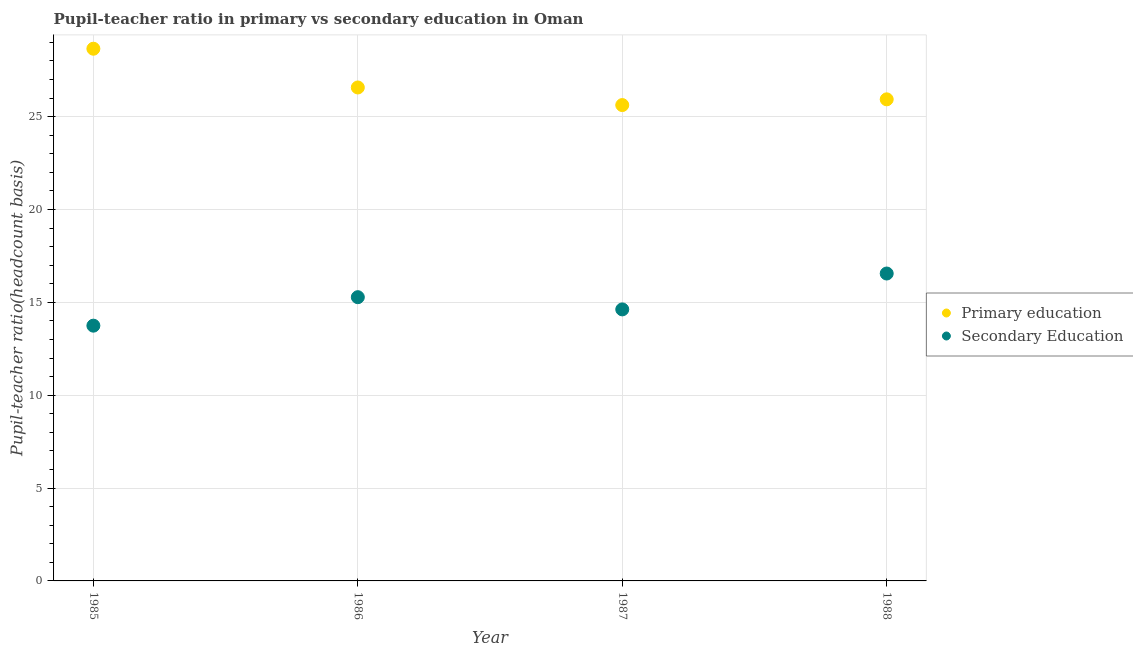Is the number of dotlines equal to the number of legend labels?
Provide a short and direct response. Yes. What is the pupil teacher ratio on secondary education in 1988?
Your answer should be compact. 16.55. Across all years, what is the maximum pupil-teacher ratio in primary education?
Offer a terse response. 28.66. Across all years, what is the minimum pupil teacher ratio on secondary education?
Give a very brief answer. 13.75. In which year was the pupil teacher ratio on secondary education maximum?
Keep it short and to the point. 1988. What is the total pupil teacher ratio on secondary education in the graph?
Offer a very short reply. 60.2. What is the difference between the pupil-teacher ratio in primary education in 1987 and that in 1988?
Your response must be concise. -0.31. What is the difference between the pupil teacher ratio on secondary education in 1987 and the pupil-teacher ratio in primary education in 1986?
Make the answer very short. -11.95. What is the average pupil-teacher ratio in primary education per year?
Offer a very short reply. 26.7. In the year 1986, what is the difference between the pupil-teacher ratio in primary education and pupil teacher ratio on secondary education?
Your response must be concise. 11.29. What is the ratio of the pupil-teacher ratio in primary education in 1985 to that in 1986?
Your answer should be very brief. 1.08. Is the pupil teacher ratio on secondary education in 1986 less than that in 1987?
Your answer should be very brief. No. Is the difference between the pupil-teacher ratio in primary education in 1986 and 1987 greater than the difference between the pupil teacher ratio on secondary education in 1986 and 1987?
Keep it short and to the point. Yes. What is the difference between the highest and the second highest pupil teacher ratio on secondary education?
Ensure brevity in your answer.  1.27. What is the difference between the highest and the lowest pupil-teacher ratio in primary education?
Ensure brevity in your answer.  3.03. Does the pupil teacher ratio on secondary education monotonically increase over the years?
Provide a short and direct response. No. Is the pupil-teacher ratio in primary education strictly greater than the pupil teacher ratio on secondary education over the years?
Make the answer very short. Yes. How many dotlines are there?
Ensure brevity in your answer.  2. How many years are there in the graph?
Your answer should be very brief. 4. What is the difference between two consecutive major ticks on the Y-axis?
Ensure brevity in your answer.  5. Does the graph contain any zero values?
Offer a terse response. No. Where does the legend appear in the graph?
Provide a short and direct response. Center right. How are the legend labels stacked?
Give a very brief answer. Vertical. What is the title of the graph?
Offer a terse response. Pupil-teacher ratio in primary vs secondary education in Oman. Does "RDB nonconcessional" appear as one of the legend labels in the graph?
Your answer should be compact. No. What is the label or title of the Y-axis?
Your answer should be very brief. Pupil-teacher ratio(headcount basis). What is the Pupil-teacher ratio(headcount basis) in Primary education in 1985?
Provide a short and direct response. 28.66. What is the Pupil-teacher ratio(headcount basis) of Secondary Education in 1985?
Your response must be concise. 13.75. What is the Pupil-teacher ratio(headcount basis) of Primary education in 1986?
Make the answer very short. 26.57. What is the Pupil-teacher ratio(headcount basis) of Secondary Education in 1986?
Your response must be concise. 15.28. What is the Pupil-teacher ratio(headcount basis) of Primary education in 1987?
Ensure brevity in your answer.  25.63. What is the Pupil-teacher ratio(headcount basis) in Secondary Education in 1987?
Your answer should be compact. 14.62. What is the Pupil-teacher ratio(headcount basis) in Primary education in 1988?
Provide a short and direct response. 25.93. What is the Pupil-teacher ratio(headcount basis) of Secondary Education in 1988?
Your answer should be very brief. 16.55. Across all years, what is the maximum Pupil-teacher ratio(headcount basis) in Primary education?
Your answer should be very brief. 28.66. Across all years, what is the maximum Pupil-teacher ratio(headcount basis) in Secondary Education?
Give a very brief answer. 16.55. Across all years, what is the minimum Pupil-teacher ratio(headcount basis) in Primary education?
Provide a succinct answer. 25.63. Across all years, what is the minimum Pupil-teacher ratio(headcount basis) of Secondary Education?
Offer a terse response. 13.75. What is the total Pupil-teacher ratio(headcount basis) in Primary education in the graph?
Offer a terse response. 106.8. What is the total Pupil-teacher ratio(headcount basis) in Secondary Education in the graph?
Your answer should be compact. 60.2. What is the difference between the Pupil-teacher ratio(headcount basis) of Primary education in 1985 and that in 1986?
Your answer should be very brief. 2.09. What is the difference between the Pupil-teacher ratio(headcount basis) of Secondary Education in 1985 and that in 1986?
Provide a short and direct response. -1.53. What is the difference between the Pupil-teacher ratio(headcount basis) in Primary education in 1985 and that in 1987?
Make the answer very short. 3.03. What is the difference between the Pupil-teacher ratio(headcount basis) in Secondary Education in 1985 and that in 1987?
Give a very brief answer. -0.88. What is the difference between the Pupil-teacher ratio(headcount basis) of Primary education in 1985 and that in 1988?
Your answer should be very brief. 2.73. What is the difference between the Pupil-teacher ratio(headcount basis) of Secondary Education in 1985 and that in 1988?
Give a very brief answer. -2.81. What is the difference between the Pupil-teacher ratio(headcount basis) in Secondary Education in 1986 and that in 1987?
Your answer should be very brief. 0.66. What is the difference between the Pupil-teacher ratio(headcount basis) of Primary education in 1986 and that in 1988?
Offer a terse response. 0.64. What is the difference between the Pupil-teacher ratio(headcount basis) of Secondary Education in 1986 and that in 1988?
Your answer should be very brief. -1.27. What is the difference between the Pupil-teacher ratio(headcount basis) in Primary education in 1987 and that in 1988?
Offer a terse response. -0.31. What is the difference between the Pupil-teacher ratio(headcount basis) in Secondary Education in 1987 and that in 1988?
Your answer should be very brief. -1.93. What is the difference between the Pupil-teacher ratio(headcount basis) of Primary education in 1985 and the Pupil-teacher ratio(headcount basis) of Secondary Education in 1986?
Provide a succinct answer. 13.38. What is the difference between the Pupil-teacher ratio(headcount basis) of Primary education in 1985 and the Pupil-teacher ratio(headcount basis) of Secondary Education in 1987?
Ensure brevity in your answer.  14.04. What is the difference between the Pupil-teacher ratio(headcount basis) in Primary education in 1985 and the Pupil-teacher ratio(headcount basis) in Secondary Education in 1988?
Make the answer very short. 12.11. What is the difference between the Pupil-teacher ratio(headcount basis) in Primary education in 1986 and the Pupil-teacher ratio(headcount basis) in Secondary Education in 1987?
Give a very brief answer. 11.95. What is the difference between the Pupil-teacher ratio(headcount basis) in Primary education in 1986 and the Pupil-teacher ratio(headcount basis) in Secondary Education in 1988?
Ensure brevity in your answer.  10.02. What is the difference between the Pupil-teacher ratio(headcount basis) of Primary education in 1987 and the Pupil-teacher ratio(headcount basis) of Secondary Education in 1988?
Ensure brevity in your answer.  9.07. What is the average Pupil-teacher ratio(headcount basis) in Primary education per year?
Ensure brevity in your answer.  26.7. What is the average Pupil-teacher ratio(headcount basis) in Secondary Education per year?
Provide a succinct answer. 15.05. In the year 1985, what is the difference between the Pupil-teacher ratio(headcount basis) in Primary education and Pupil-teacher ratio(headcount basis) in Secondary Education?
Your response must be concise. 14.91. In the year 1986, what is the difference between the Pupil-teacher ratio(headcount basis) in Primary education and Pupil-teacher ratio(headcount basis) in Secondary Education?
Give a very brief answer. 11.29. In the year 1987, what is the difference between the Pupil-teacher ratio(headcount basis) of Primary education and Pupil-teacher ratio(headcount basis) of Secondary Education?
Offer a very short reply. 11. In the year 1988, what is the difference between the Pupil-teacher ratio(headcount basis) in Primary education and Pupil-teacher ratio(headcount basis) in Secondary Education?
Provide a succinct answer. 9.38. What is the ratio of the Pupil-teacher ratio(headcount basis) in Primary education in 1985 to that in 1986?
Ensure brevity in your answer.  1.08. What is the ratio of the Pupil-teacher ratio(headcount basis) of Secondary Education in 1985 to that in 1986?
Give a very brief answer. 0.9. What is the ratio of the Pupil-teacher ratio(headcount basis) in Primary education in 1985 to that in 1987?
Give a very brief answer. 1.12. What is the ratio of the Pupil-teacher ratio(headcount basis) of Secondary Education in 1985 to that in 1987?
Ensure brevity in your answer.  0.94. What is the ratio of the Pupil-teacher ratio(headcount basis) in Primary education in 1985 to that in 1988?
Your answer should be very brief. 1.11. What is the ratio of the Pupil-teacher ratio(headcount basis) of Secondary Education in 1985 to that in 1988?
Ensure brevity in your answer.  0.83. What is the ratio of the Pupil-teacher ratio(headcount basis) of Secondary Education in 1986 to that in 1987?
Provide a short and direct response. 1.04. What is the ratio of the Pupil-teacher ratio(headcount basis) of Primary education in 1986 to that in 1988?
Your response must be concise. 1.02. What is the ratio of the Pupil-teacher ratio(headcount basis) of Secondary Education in 1986 to that in 1988?
Your answer should be very brief. 0.92. What is the ratio of the Pupil-teacher ratio(headcount basis) in Primary education in 1987 to that in 1988?
Your response must be concise. 0.99. What is the ratio of the Pupil-teacher ratio(headcount basis) of Secondary Education in 1987 to that in 1988?
Provide a succinct answer. 0.88. What is the difference between the highest and the second highest Pupil-teacher ratio(headcount basis) in Primary education?
Provide a succinct answer. 2.09. What is the difference between the highest and the second highest Pupil-teacher ratio(headcount basis) of Secondary Education?
Offer a very short reply. 1.27. What is the difference between the highest and the lowest Pupil-teacher ratio(headcount basis) of Primary education?
Ensure brevity in your answer.  3.03. What is the difference between the highest and the lowest Pupil-teacher ratio(headcount basis) of Secondary Education?
Provide a succinct answer. 2.81. 